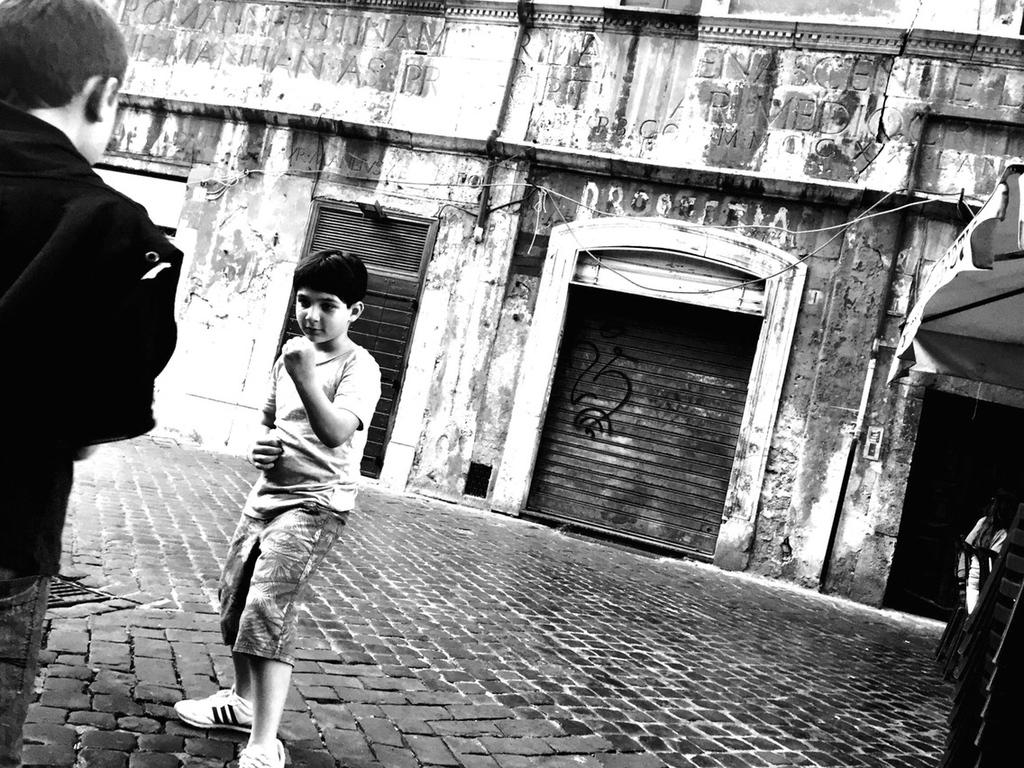What is the color scheme of the image? The image is black and white. Who is the main subject in the image? There is a boy in the image. Can you describe the person on the left side of the image? There is another person on the left side of the image. What type of buildings can be seen in the background of the image? There are buildings with shutters in the background of the image. What is written on the buildings? There is writing on the buildings. What type of twig can be seen in the boy's hand in the image? There is no twig visible in the boy's hand in the image. What type of voyage is the boy embarking on in the image? There is no indication of a voyage in the image; it simply shows a boy and another person. 